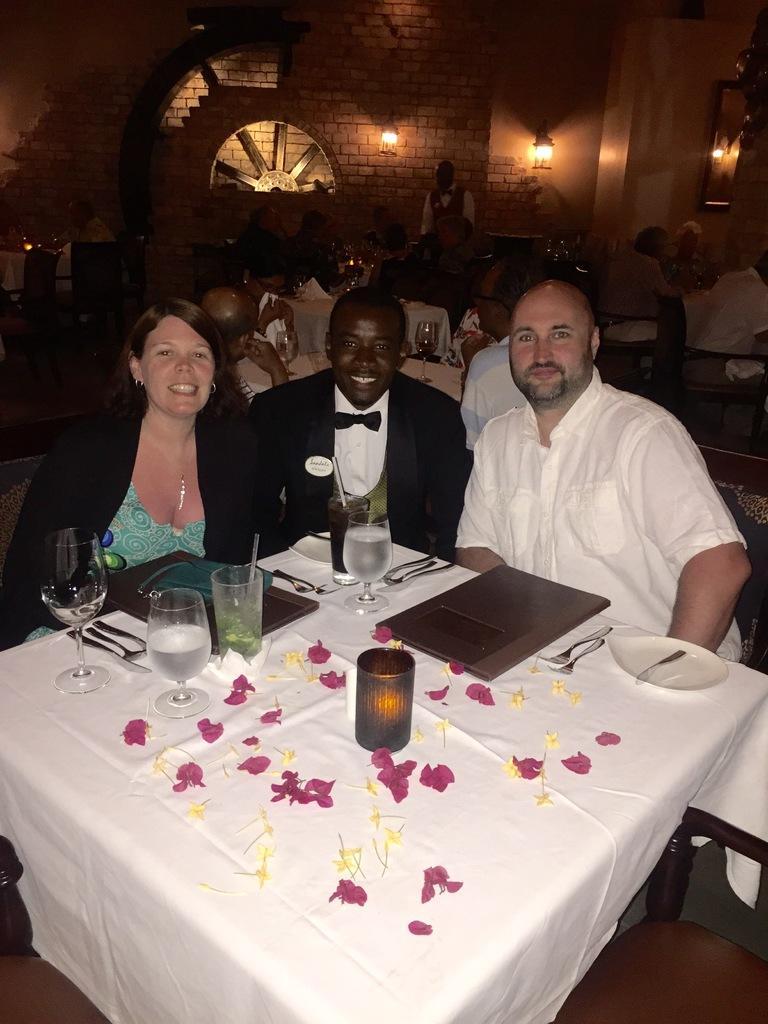How would you summarize this image in a sentence or two? There are three people sitting on the chairs. This is the table covered with white cloth. There is a plate,tumblers,flowers and spoons and this is looks like a menu card placed on the table. At background I can see few people sitting and a person standing. These are the lamps,I think these are attached to the wall. 